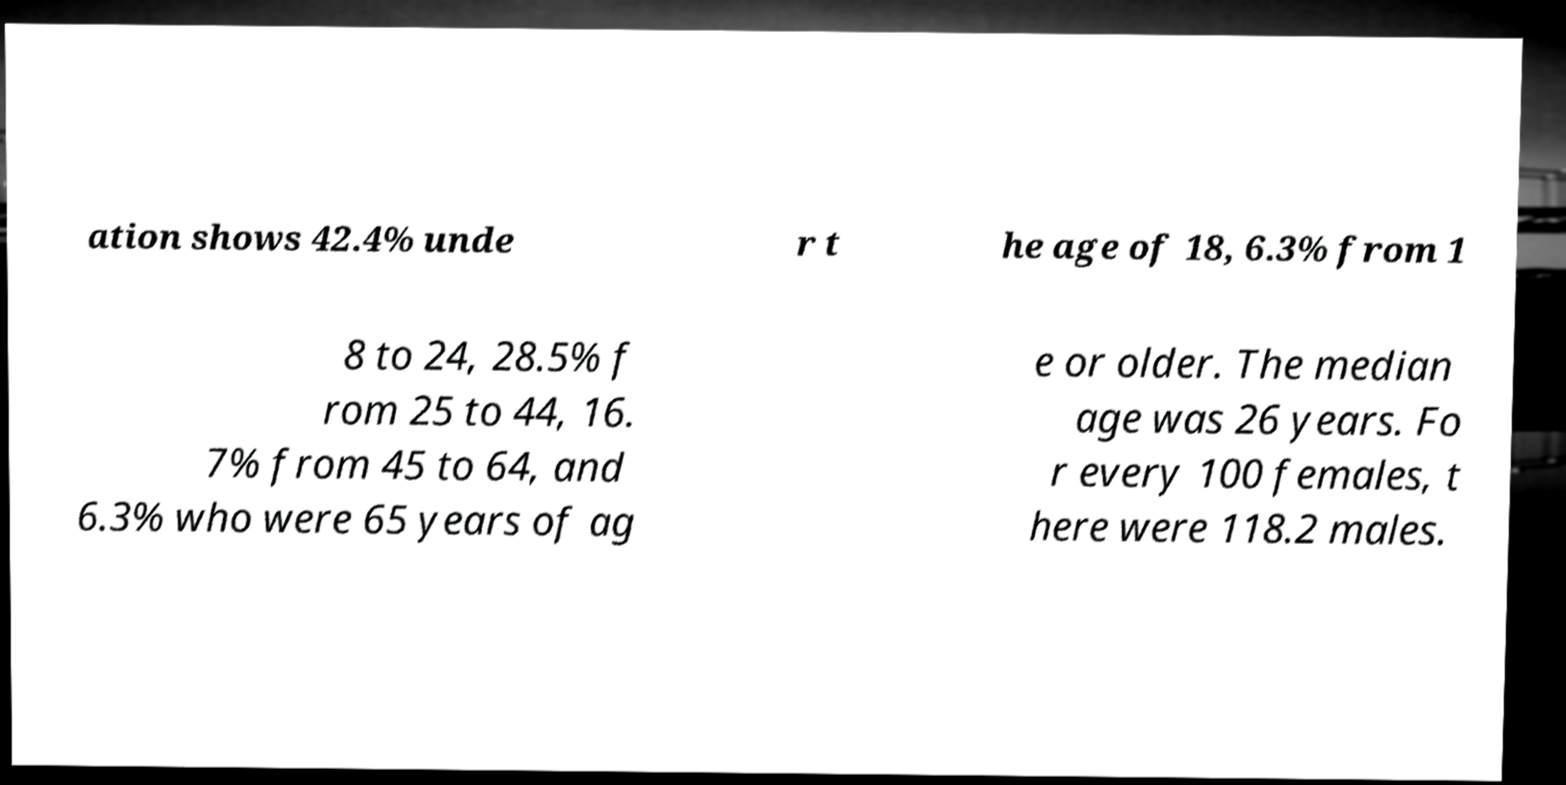There's text embedded in this image that I need extracted. Can you transcribe it verbatim? ation shows 42.4% unde r t he age of 18, 6.3% from 1 8 to 24, 28.5% f rom 25 to 44, 16. 7% from 45 to 64, and 6.3% who were 65 years of ag e or older. The median age was 26 years. Fo r every 100 females, t here were 118.2 males. 